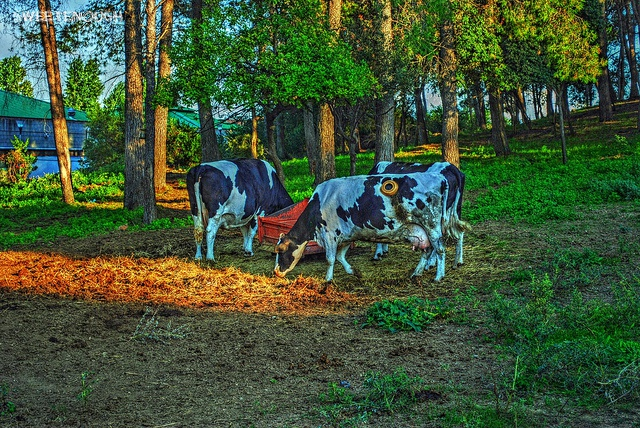Describe the objects in this image and their specific colors. I can see cow in lightblue, black, and teal tones, cow in lightblue, black, navy, teal, and blue tones, cow in lightblue, black, navy, blue, and teal tones, and car in lightblue, gray, blue, and black tones in this image. 